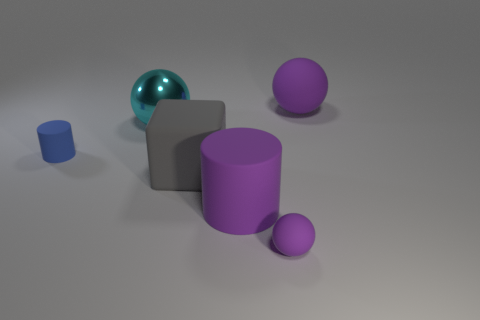Is there anything else that is the same material as the cyan object?
Give a very brief answer. No. The tiny purple object that is the same material as the block is what shape?
Your answer should be compact. Sphere. Is there any other thing that has the same color as the big matte cylinder?
Keep it short and to the point. Yes. Is the number of cyan things that are behind the blue thing greater than the number of tiny red metallic cylinders?
Provide a short and direct response. Yes. What material is the cyan sphere?
Provide a succinct answer. Metal. What number of things have the same size as the blue cylinder?
Your answer should be compact. 1. Is the number of blue rubber things that are right of the tiny cylinder the same as the number of rubber cylinders that are to the right of the large cyan metal thing?
Offer a very short reply. No. Do the large purple cylinder and the large purple sphere have the same material?
Ensure brevity in your answer.  Yes. Are there any small blue objects behind the purple matte object behind the large gray cube?
Offer a terse response. No. Are there any small blue metallic objects of the same shape as the gray thing?
Your answer should be very brief. No. 